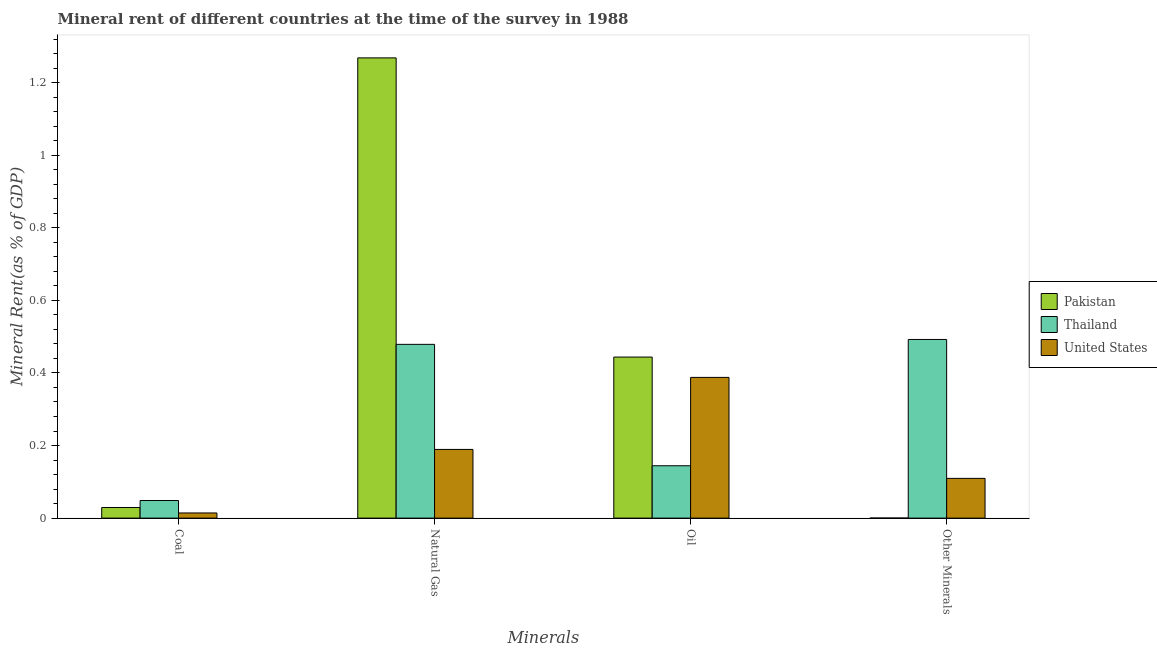How many groups of bars are there?
Offer a very short reply. 4. Are the number of bars on each tick of the X-axis equal?
Give a very brief answer. Yes. How many bars are there on the 3rd tick from the left?
Provide a succinct answer. 3. How many bars are there on the 1st tick from the right?
Your response must be concise. 3. What is the label of the 2nd group of bars from the left?
Give a very brief answer. Natural Gas. What is the natural gas rent in Thailand?
Offer a terse response. 0.48. Across all countries, what is the maximum natural gas rent?
Offer a terse response. 1.27. Across all countries, what is the minimum coal rent?
Your answer should be very brief. 0.01. In which country was the coal rent maximum?
Ensure brevity in your answer.  Thailand. What is the total  rent of other minerals in the graph?
Your answer should be compact. 0.6. What is the difference between the natural gas rent in Pakistan and that in United States?
Your response must be concise. 1.08. What is the difference between the natural gas rent in Pakistan and the  rent of other minerals in United States?
Provide a succinct answer. 1.16. What is the average  rent of other minerals per country?
Offer a very short reply. 0.2. What is the difference between the oil rent and natural gas rent in Thailand?
Provide a succinct answer. -0.33. In how many countries, is the  rent of other minerals greater than 0.04 %?
Offer a terse response. 2. What is the ratio of the coal rent in Pakistan to that in Thailand?
Offer a very short reply. 0.6. What is the difference between the highest and the second highest natural gas rent?
Keep it short and to the point. 0.79. What is the difference between the highest and the lowest natural gas rent?
Make the answer very short. 1.08. What does the 2nd bar from the left in Other Minerals represents?
Your answer should be compact. Thailand. What does the 2nd bar from the right in Other Minerals represents?
Make the answer very short. Thailand. Is it the case that in every country, the sum of the coal rent and natural gas rent is greater than the oil rent?
Give a very brief answer. No. How many bars are there?
Your answer should be compact. 12. Are all the bars in the graph horizontal?
Your response must be concise. No. How many countries are there in the graph?
Your answer should be very brief. 3. Are the values on the major ticks of Y-axis written in scientific E-notation?
Provide a succinct answer. No. Does the graph contain any zero values?
Ensure brevity in your answer.  No. Does the graph contain grids?
Your answer should be compact. No. How many legend labels are there?
Ensure brevity in your answer.  3. How are the legend labels stacked?
Offer a terse response. Vertical. What is the title of the graph?
Your response must be concise. Mineral rent of different countries at the time of the survey in 1988. Does "Japan" appear as one of the legend labels in the graph?
Your response must be concise. No. What is the label or title of the X-axis?
Your answer should be compact. Minerals. What is the label or title of the Y-axis?
Make the answer very short. Mineral Rent(as % of GDP). What is the Mineral Rent(as % of GDP) in Pakistan in Coal?
Ensure brevity in your answer.  0.03. What is the Mineral Rent(as % of GDP) in Thailand in Coal?
Give a very brief answer. 0.05. What is the Mineral Rent(as % of GDP) of United States in Coal?
Keep it short and to the point. 0.01. What is the Mineral Rent(as % of GDP) in Pakistan in Natural Gas?
Your answer should be very brief. 1.27. What is the Mineral Rent(as % of GDP) of Thailand in Natural Gas?
Keep it short and to the point. 0.48. What is the Mineral Rent(as % of GDP) in United States in Natural Gas?
Make the answer very short. 0.19. What is the Mineral Rent(as % of GDP) in Pakistan in Oil?
Offer a very short reply. 0.44. What is the Mineral Rent(as % of GDP) in Thailand in Oil?
Provide a short and direct response. 0.14. What is the Mineral Rent(as % of GDP) of United States in Oil?
Keep it short and to the point. 0.39. What is the Mineral Rent(as % of GDP) of Pakistan in Other Minerals?
Provide a succinct answer. 0. What is the Mineral Rent(as % of GDP) in Thailand in Other Minerals?
Keep it short and to the point. 0.49. What is the Mineral Rent(as % of GDP) of United States in Other Minerals?
Make the answer very short. 0.11. Across all Minerals, what is the maximum Mineral Rent(as % of GDP) of Pakistan?
Make the answer very short. 1.27. Across all Minerals, what is the maximum Mineral Rent(as % of GDP) in Thailand?
Offer a terse response. 0.49. Across all Minerals, what is the maximum Mineral Rent(as % of GDP) of United States?
Offer a terse response. 0.39. Across all Minerals, what is the minimum Mineral Rent(as % of GDP) of Pakistan?
Offer a terse response. 0. Across all Minerals, what is the minimum Mineral Rent(as % of GDP) in Thailand?
Give a very brief answer. 0.05. Across all Minerals, what is the minimum Mineral Rent(as % of GDP) of United States?
Provide a short and direct response. 0.01. What is the total Mineral Rent(as % of GDP) in Pakistan in the graph?
Ensure brevity in your answer.  1.74. What is the total Mineral Rent(as % of GDP) of Thailand in the graph?
Your answer should be compact. 1.16. What is the total Mineral Rent(as % of GDP) in United States in the graph?
Make the answer very short. 0.7. What is the difference between the Mineral Rent(as % of GDP) in Pakistan in Coal and that in Natural Gas?
Your answer should be very brief. -1.24. What is the difference between the Mineral Rent(as % of GDP) in Thailand in Coal and that in Natural Gas?
Your answer should be compact. -0.43. What is the difference between the Mineral Rent(as % of GDP) in United States in Coal and that in Natural Gas?
Your answer should be compact. -0.17. What is the difference between the Mineral Rent(as % of GDP) in Pakistan in Coal and that in Oil?
Provide a short and direct response. -0.41. What is the difference between the Mineral Rent(as % of GDP) of Thailand in Coal and that in Oil?
Provide a short and direct response. -0.1. What is the difference between the Mineral Rent(as % of GDP) in United States in Coal and that in Oil?
Your answer should be very brief. -0.37. What is the difference between the Mineral Rent(as % of GDP) of Pakistan in Coal and that in Other Minerals?
Keep it short and to the point. 0.03. What is the difference between the Mineral Rent(as % of GDP) of Thailand in Coal and that in Other Minerals?
Provide a short and direct response. -0.44. What is the difference between the Mineral Rent(as % of GDP) in United States in Coal and that in Other Minerals?
Your answer should be compact. -0.1. What is the difference between the Mineral Rent(as % of GDP) in Pakistan in Natural Gas and that in Oil?
Your answer should be compact. 0.82. What is the difference between the Mineral Rent(as % of GDP) of Thailand in Natural Gas and that in Oil?
Your answer should be very brief. 0.33. What is the difference between the Mineral Rent(as % of GDP) of United States in Natural Gas and that in Oil?
Keep it short and to the point. -0.2. What is the difference between the Mineral Rent(as % of GDP) of Pakistan in Natural Gas and that in Other Minerals?
Your answer should be very brief. 1.27. What is the difference between the Mineral Rent(as % of GDP) in Thailand in Natural Gas and that in Other Minerals?
Give a very brief answer. -0.01. What is the difference between the Mineral Rent(as % of GDP) in United States in Natural Gas and that in Other Minerals?
Offer a terse response. 0.08. What is the difference between the Mineral Rent(as % of GDP) of Pakistan in Oil and that in Other Minerals?
Keep it short and to the point. 0.44. What is the difference between the Mineral Rent(as % of GDP) of Thailand in Oil and that in Other Minerals?
Keep it short and to the point. -0.35. What is the difference between the Mineral Rent(as % of GDP) in United States in Oil and that in Other Minerals?
Keep it short and to the point. 0.28. What is the difference between the Mineral Rent(as % of GDP) of Pakistan in Coal and the Mineral Rent(as % of GDP) of Thailand in Natural Gas?
Offer a very short reply. -0.45. What is the difference between the Mineral Rent(as % of GDP) of Pakistan in Coal and the Mineral Rent(as % of GDP) of United States in Natural Gas?
Keep it short and to the point. -0.16. What is the difference between the Mineral Rent(as % of GDP) in Thailand in Coal and the Mineral Rent(as % of GDP) in United States in Natural Gas?
Provide a succinct answer. -0.14. What is the difference between the Mineral Rent(as % of GDP) in Pakistan in Coal and the Mineral Rent(as % of GDP) in Thailand in Oil?
Keep it short and to the point. -0.12. What is the difference between the Mineral Rent(as % of GDP) of Pakistan in Coal and the Mineral Rent(as % of GDP) of United States in Oil?
Offer a very short reply. -0.36. What is the difference between the Mineral Rent(as % of GDP) in Thailand in Coal and the Mineral Rent(as % of GDP) in United States in Oil?
Your answer should be compact. -0.34. What is the difference between the Mineral Rent(as % of GDP) in Pakistan in Coal and the Mineral Rent(as % of GDP) in Thailand in Other Minerals?
Ensure brevity in your answer.  -0.46. What is the difference between the Mineral Rent(as % of GDP) of Pakistan in Coal and the Mineral Rent(as % of GDP) of United States in Other Minerals?
Ensure brevity in your answer.  -0.08. What is the difference between the Mineral Rent(as % of GDP) in Thailand in Coal and the Mineral Rent(as % of GDP) in United States in Other Minerals?
Offer a terse response. -0.06. What is the difference between the Mineral Rent(as % of GDP) in Pakistan in Natural Gas and the Mineral Rent(as % of GDP) in Thailand in Oil?
Your response must be concise. 1.12. What is the difference between the Mineral Rent(as % of GDP) in Pakistan in Natural Gas and the Mineral Rent(as % of GDP) in United States in Oil?
Provide a succinct answer. 0.88. What is the difference between the Mineral Rent(as % of GDP) of Thailand in Natural Gas and the Mineral Rent(as % of GDP) of United States in Oil?
Provide a short and direct response. 0.09. What is the difference between the Mineral Rent(as % of GDP) of Pakistan in Natural Gas and the Mineral Rent(as % of GDP) of Thailand in Other Minerals?
Give a very brief answer. 0.78. What is the difference between the Mineral Rent(as % of GDP) of Pakistan in Natural Gas and the Mineral Rent(as % of GDP) of United States in Other Minerals?
Offer a terse response. 1.16. What is the difference between the Mineral Rent(as % of GDP) of Thailand in Natural Gas and the Mineral Rent(as % of GDP) of United States in Other Minerals?
Ensure brevity in your answer.  0.37. What is the difference between the Mineral Rent(as % of GDP) of Pakistan in Oil and the Mineral Rent(as % of GDP) of Thailand in Other Minerals?
Your response must be concise. -0.05. What is the difference between the Mineral Rent(as % of GDP) in Pakistan in Oil and the Mineral Rent(as % of GDP) in United States in Other Minerals?
Your answer should be very brief. 0.33. What is the difference between the Mineral Rent(as % of GDP) of Thailand in Oil and the Mineral Rent(as % of GDP) of United States in Other Minerals?
Offer a terse response. 0.03. What is the average Mineral Rent(as % of GDP) of Pakistan per Minerals?
Provide a succinct answer. 0.44. What is the average Mineral Rent(as % of GDP) in Thailand per Minerals?
Offer a very short reply. 0.29. What is the average Mineral Rent(as % of GDP) in United States per Minerals?
Give a very brief answer. 0.18. What is the difference between the Mineral Rent(as % of GDP) of Pakistan and Mineral Rent(as % of GDP) of Thailand in Coal?
Your answer should be very brief. -0.02. What is the difference between the Mineral Rent(as % of GDP) of Pakistan and Mineral Rent(as % of GDP) of United States in Coal?
Your response must be concise. 0.02. What is the difference between the Mineral Rent(as % of GDP) in Thailand and Mineral Rent(as % of GDP) in United States in Coal?
Your response must be concise. 0.03. What is the difference between the Mineral Rent(as % of GDP) of Pakistan and Mineral Rent(as % of GDP) of Thailand in Natural Gas?
Provide a short and direct response. 0.79. What is the difference between the Mineral Rent(as % of GDP) of Pakistan and Mineral Rent(as % of GDP) of United States in Natural Gas?
Give a very brief answer. 1.08. What is the difference between the Mineral Rent(as % of GDP) of Thailand and Mineral Rent(as % of GDP) of United States in Natural Gas?
Ensure brevity in your answer.  0.29. What is the difference between the Mineral Rent(as % of GDP) in Pakistan and Mineral Rent(as % of GDP) in Thailand in Oil?
Keep it short and to the point. 0.3. What is the difference between the Mineral Rent(as % of GDP) in Pakistan and Mineral Rent(as % of GDP) in United States in Oil?
Offer a terse response. 0.06. What is the difference between the Mineral Rent(as % of GDP) in Thailand and Mineral Rent(as % of GDP) in United States in Oil?
Your answer should be very brief. -0.24. What is the difference between the Mineral Rent(as % of GDP) in Pakistan and Mineral Rent(as % of GDP) in Thailand in Other Minerals?
Your answer should be compact. -0.49. What is the difference between the Mineral Rent(as % of GDP) in Pakistan and Mineral Rent(as % of GDP) in United States in Other Minerals?
Your answer should be very brief. -0.11. What is the difference between the Mineral Rent(as % of GDP) of Thailand and Mineral Rent(as % of GDP) of United States in Other Minerals?
Make the answer very short. 0.38. What is the ratio of the Mineral Rent(as % of GDP) of Pakistan in Coal to that in Natural Gas?
Your answer should be very brief. 0.02. What is the ratio of the Mineral Rent(as % of GDP) in Thailand in Coal to that in Natural Gas?
Offer a very short reply. 0.1. What is the ratio of the Mineral Rent(as % of GDP) of United States in Coal to that in Natural Gas?
Make the answer very short. 0.08. What is the ratio of the Mineral Rent(as % of GDP) in Pakistan in Coal to that in Oil?
Make the answer very short. 0.07. What is the ratio of the Mineral Rent(as % of GDP) of Thailand in Coal to that in Oil?
Ensure brevity in your answer.  0.34. What is the ratio of the Mineral Rent(as % of GDP) in United States in Coal to that in Oil?
Provide a short and direct response. 0.04. What is the ratio of the Mineral Rent(as % of GDP) of Pakistan in Coal to that in Other Minerals?
Give a very brief answer. 180.05. What is the ratio of the Mineral Rent(as % of GDP) of Thailand in Coal to that in Other Minerals?
Give a very brief answer. 0.1. What is the ratio of the Mineral Rent(as % of GDP) of United States in Coal to that in Other Minerals?
Keep it short and to the point. 0.13. What is the ratio of the Mineral Rent(as % of GDP) of Pakistan in Natural Gas to that in Oil?
Give a very brief answer. 2.86. What is the ratio of the Mineral Rent(as % of GDP) of Thailand in Natural Gas to that in Oil?
Give a very brief answer. 3.32. What is the ratio of the Mineral Rent(as % of GDP) of United States in Natural Gas to that in Oil?
Your answer should be compact. 0.49. What is the ratio of the Mineral Rent(as % of GDP) in Pakistan in Natural Gas to that in Other Minerals?
Give a very brief answer. 7801.96. What is the ratio of the Mineral Rent(as % of GDP) of Thailand in Natural Gas to that in Other Minerals?
Offer a terse response. 0.97. What is the ratio of the Mineral Rent(as % of GDP) of United States in Natural Gas to that in Other Minerals?
Ensure brevity in your answer.  1.73. What is the ratio of the Mineral Rent(as % of GDP) in Pakistan in Oil to that in Other Minerals?
Your response must be concise. 2730.04. What is the ratio of the Mineral Rent(as % of GDP) of Thailand in Oil to that in Other Minerals?
Offer a very short reply. 0.29. What is the ratio of the Mineral Rent(as % of GDP) in United States in Oil to that in Other Minerals?
Ensure brevity in your answer.  3.54. What is the difference between the highest and the second highest Mineral Rent(as % of GDP) of Pakistan?
Give a very brief answer. 0.82. What is the difference between the highest and the second highest Mineral Rent(as % of GDP) in Thailand?
Provide a short and direct response. 0.01. What is the difference between the highest and the second highest Mineral Rent(as % of GDP) in United States?
Your answer should be compact. 0.2. What is the difference between the highest and the lowest Mineral Rent(as % of GDP) of Pakistan?
Your answer should be compact. 1.27. What is the difference between the highest and the lowest Mineral Rent(as % of GDP) of Thailand?
Provide a succinct answer. 0.44. What is the difference between the highest and the lowest Mineral Rent(as % of GDP) in United States?
Offer a terse response. 0.37. 